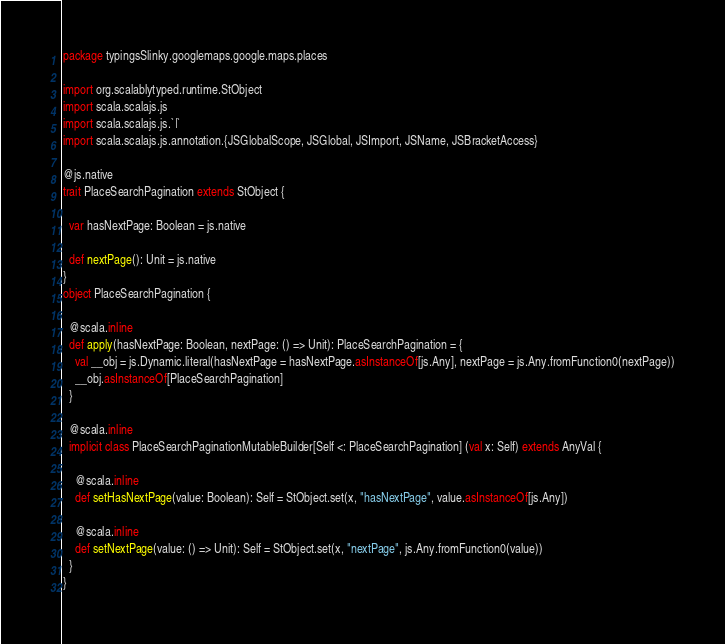<code> <loc_0><loc_0><loc_500><loc_500><_Scala_>package typingsSlinky.googlemaps.google.maps.places

import org.scalablytyped.runtime.StObject
import scala.scalajs.js
import scala.scalajs.js.`|`
import scala.scalajs.js.annotation.{JSGlobalScope, JSGlobal, JSImport, JSName, JSBracketAccess}

@js.native
trait PlaceSearchPagination extends StObject {
  
  var hasNextPage: Boolean = js.native
  
  def nextPage(): Unit = js.native
}
object PlaceSearchPagination {
  
  @scala.inline
  def apply(hasNextPage: Boolean, nextPage: () => Unit): PlaceSearchPagination = {
    val __obj = js.Dynamic.literal(hasNextPage = hasNextPage.asInstanceOf[js.Any], nextPage = js.Any.fromFunction0(nextPage))
    __obj.asInstanceOf[PlaceSearchPagination]
  }
  
  @scala.inline
  implicit class PlaceSearchPaginationMutableBuilder[Self <: PlaceSearchPagination] (val x: Self) extends AnyVal {
    
    @scala.inline
    def setHasNextPage(value: Boolean): Self = StObject.set(x, "hasNextPage", value.asInstanceOf[js.Any])
    
    @scala.inline
    def setNextPage(value: () => Unit): Self = StObject.set(x, "nextPage", js.Any.fromFunction0(value))
  }
}
</code> 